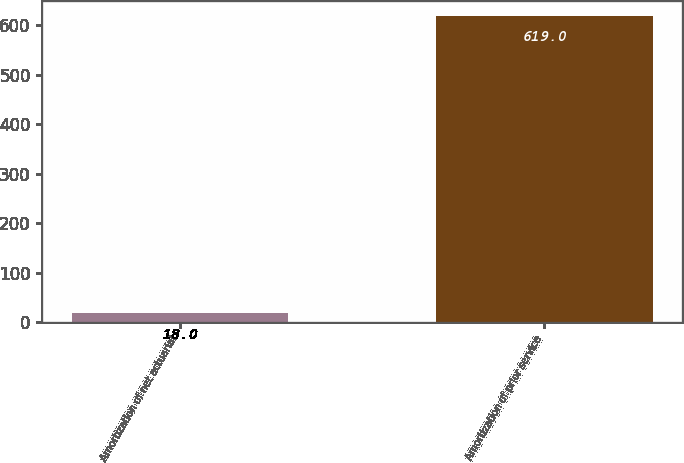Convert chart to OTSL. <chart><loc_0><loc_0><loc_500><loc_500><bar_chart><fcel>Amortization of net actuarial<fcel>Amortization of prior service<nl><fcel>18<fcel>619<nl></chart> 